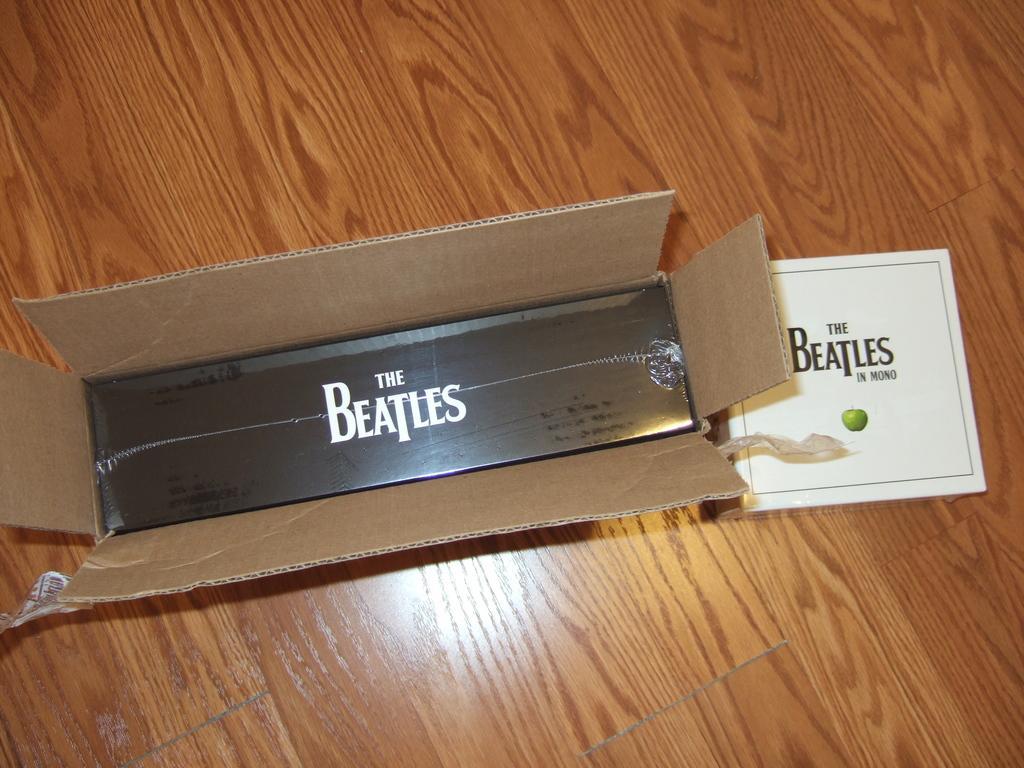Can you describe this image briefly? In this picture I can see a box in front in which there is a black color thing, on which there is something written and side to this box I see a white color paper, on which there is something written too and these 2 things are on the brown color surface. 